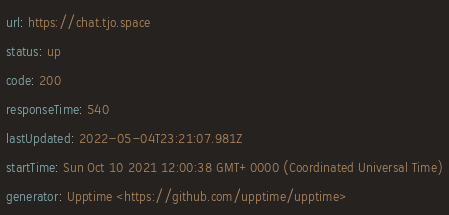Convert code to text. <code><loc_0><loc_0><loc_500><loc_500><_YAML_>url: https://chat.tjo.space
status: up
code: 200
responseTime: 540
lastUpdated: 2022-05-04T23:21:07.981Z
startTime: Sun Oct 10 2021 12:00:38 GMT+0000 (Coordinated Universal Time)
generator: Upptime <https://github.com/upptime/upptime>
</code> 